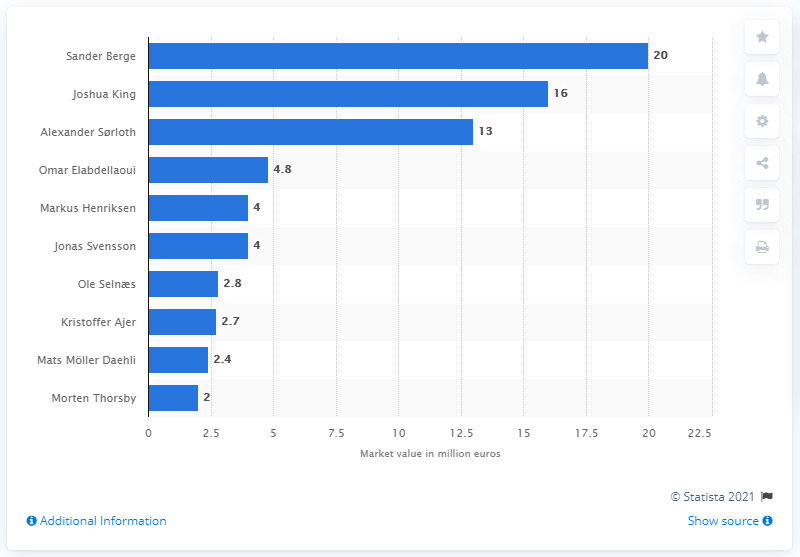Point out several critical features in this image. Alexander Sroth had a market value of 13. Sander Berge was named the most valuable football player in Norway in 2020. As of 2020, Sander Berge's market value was [insert value]. In 2017, the estimated market value of Joshua King was approximately 16 million dollars. 